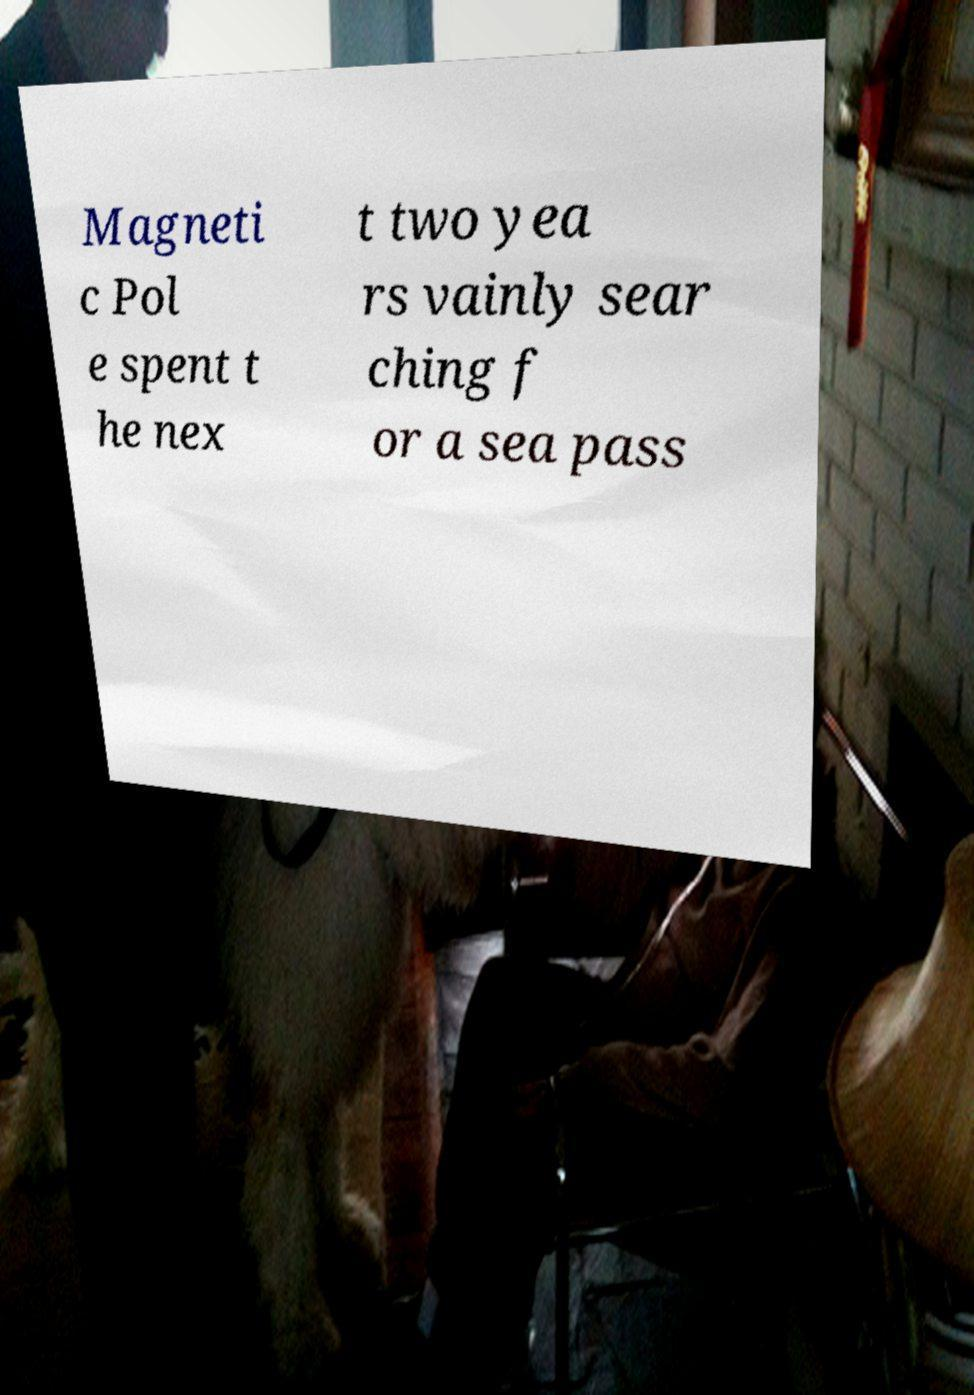Please read and relay the text visible in this image. What does it say? Magneti c Pol e spent t he nex t two yea rs vainly sear ching f or a sea pass 